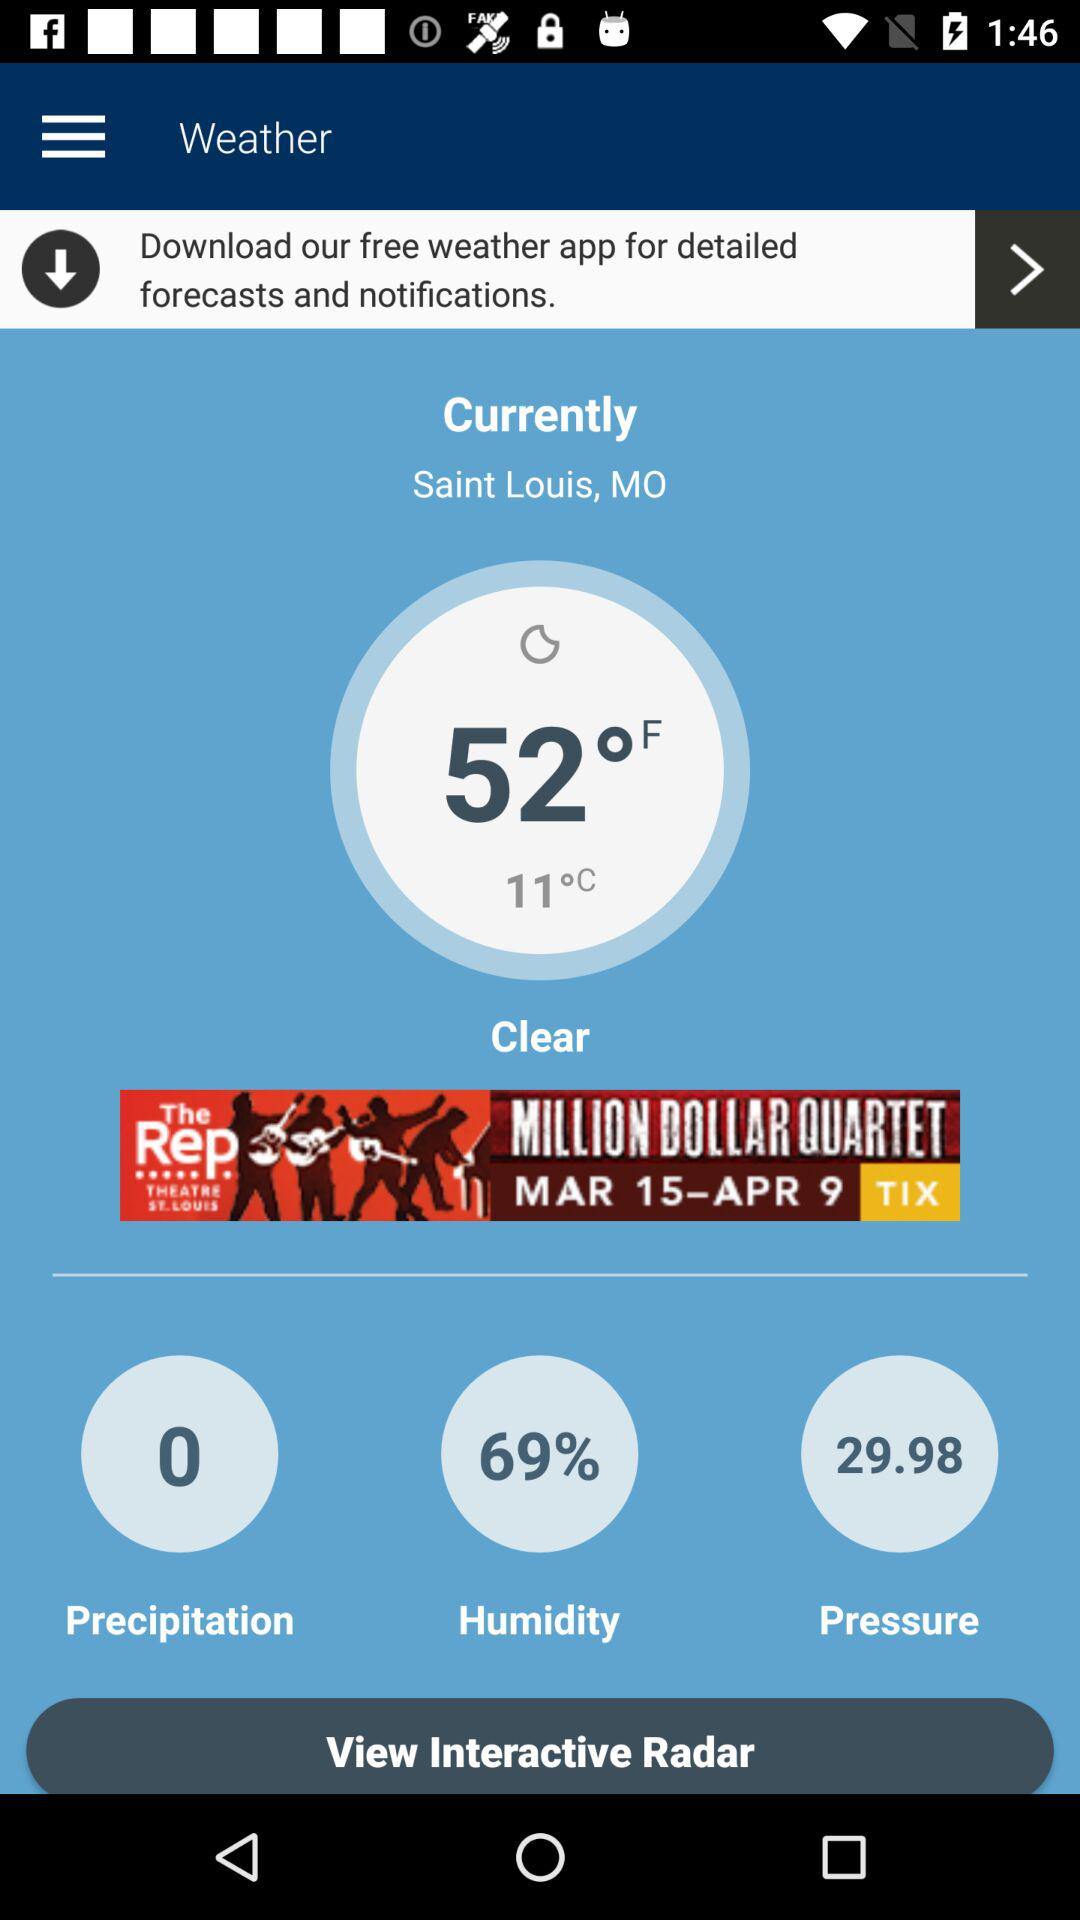What's the temperature and weather? The temperature is 52°F and the weather is clear. 